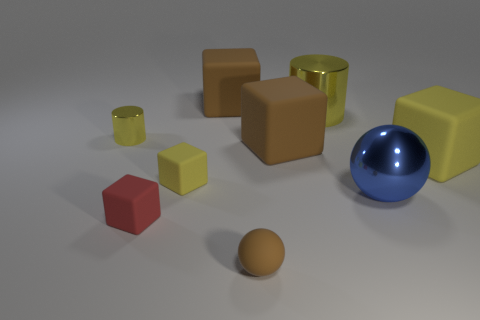The large rubber thing that is the same color as the tiny shiny thing is what shape?
Make the answer very short. Cube. The tiny sphere has what color?
Provide a succinct answer. Brown. Does the tiny matte ball have the same color as the rubber block behind the tiny metallic cylinder?
Ensure brevity in your answer.  Yes. There is a yellow thing that is the same material as the small yellow cube; what is its size?
Offer a terse response. Large. Is there a big matte cube that has the same color as the matte sphere?
Give a very brief answer. Yes. There is a metallic thing that is the same color as the big metallic cylinder; what is its size?
Provide a succinct answer. Small. Do the tiny cylinder and the large cylinder have the same color?
Make the answer very short. Yes. What is the shape of the large metallic object that is in front of the big yellow metal cylinder that is behind the big yellow cube?
Your response must be concise. Sphere. Is the number of tiny objects less than the number of cubes?
Provide a succinct answer. Yes. There is a thing that is both behind the tiny yellow metallic cylinder and left of the small brown matte thing; what size is it?
Offer a very short reply. Large. 